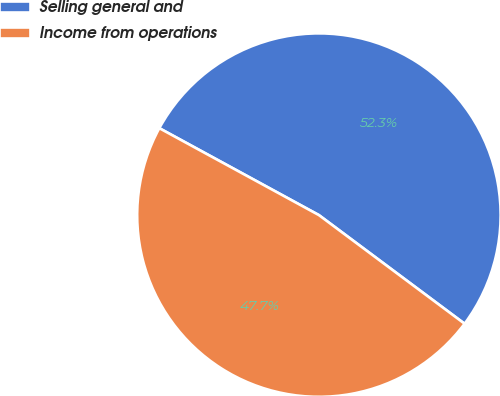Convert chart to OTSL. <chart><loc_0><loc_0><loc_500><loc_500><pie_chart><fcel>Selling general and<fcel>Income from operations<nl><fcel>52.26%<fcel>47.74%<nl></chart> 